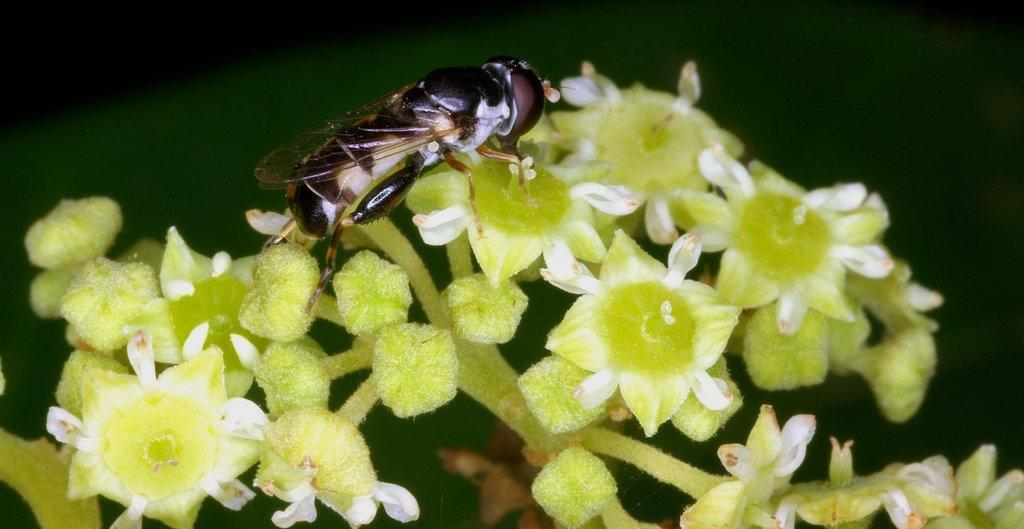What is on the flower in the image? There is an insect on the flower in the image. What color is the background of the image? The background of the image is green. What can be seen on the plant stem in the image? There is a plant stem with flowers and buds in the image. What type of bean is growing on the plant stem in the image? There is no bean present in the image; it features an insect on a flower and a plant stem with flowers and buds. Can you see a boot in the image? There is no boot present in the image. 